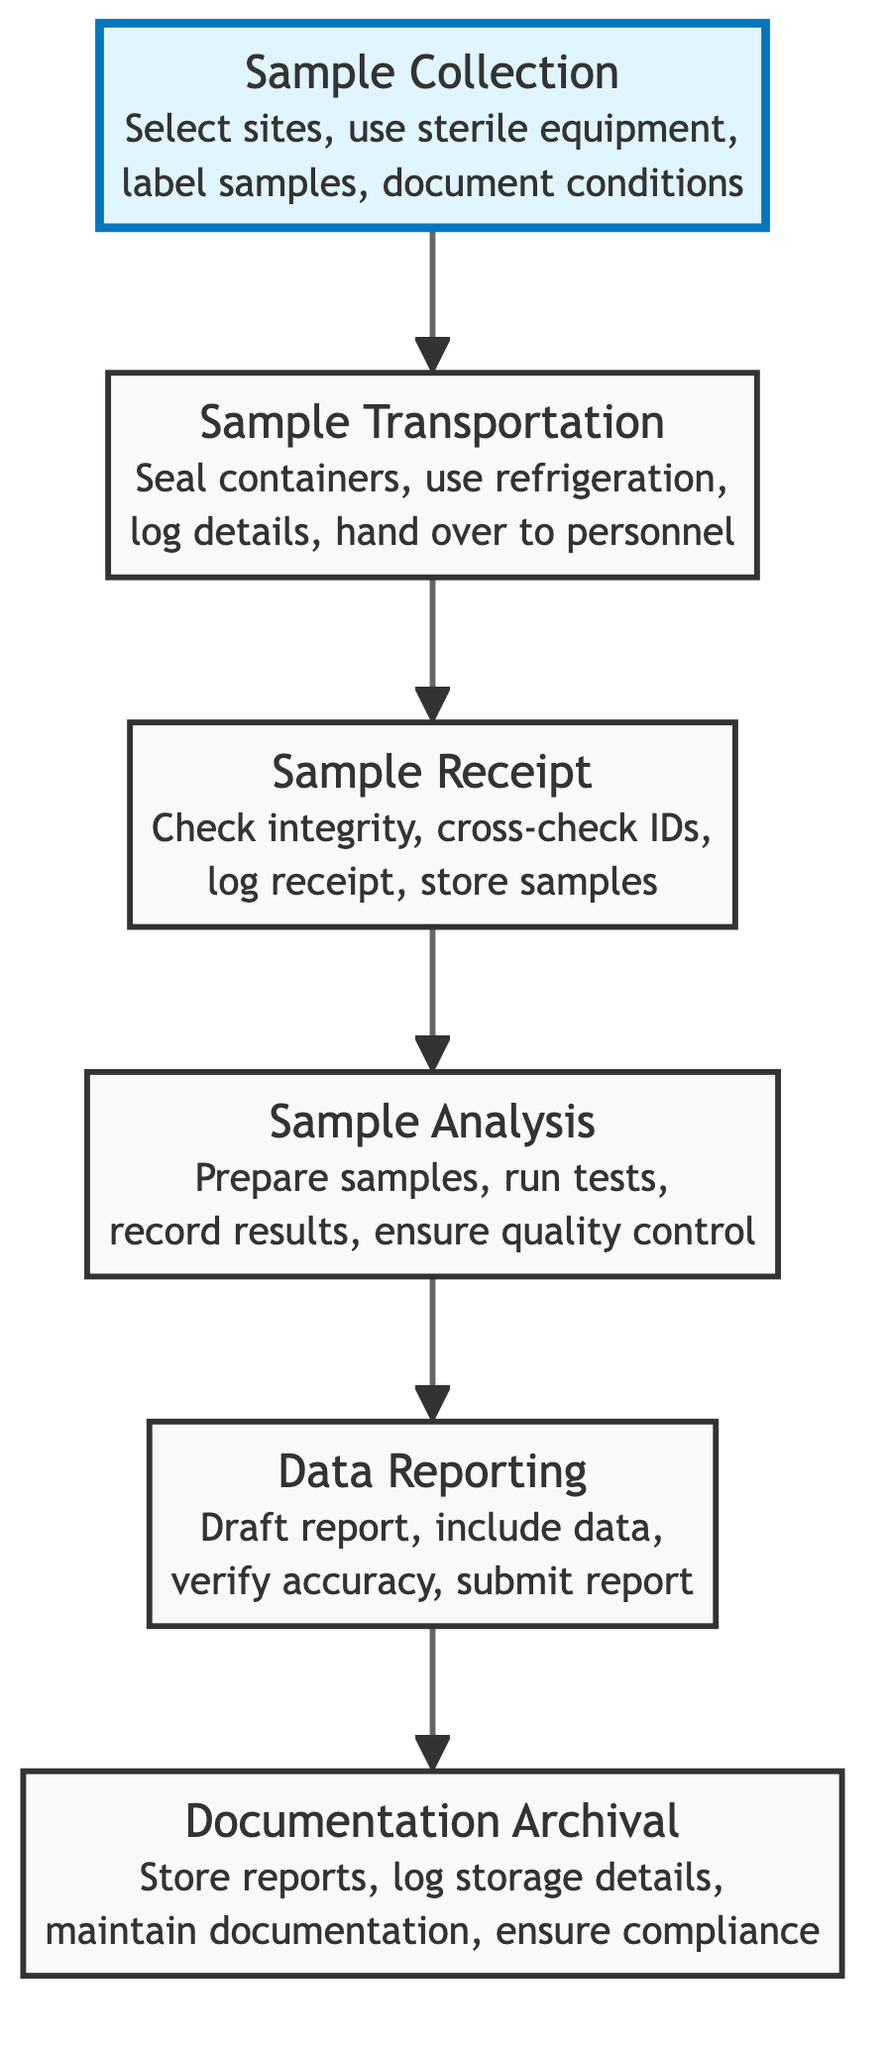What is the first step in the chain of custody documentation process? The flowchart indicates that the first step is "Sample Collection," which involves selecting sampling sites and using sterilized equipment.
Answer: Sample Collection How many nodes are present in the diagram? The diagram contains six nodes representing different steps in the chain of custody documentation process.
Answer: Six Which step is responsible for ensuring compliance with legal requirements? The node "Documentation Archival" is responsible for maintaining compliance with legal requirements following the completion of previous steps.
Answer: Documentation Archival What action is taken in the "Sample Transportation" step? This step includes actions such as placing samples in sealed containers, using refrigerated transport if necessary, and logging transportation details.
Answer: Place samples in sealed containers What does the "Data Reporting" step entail? The "Data Reporting" step includes drafting a detailed report, verifying report accuracy, and submitting the report to relevant parties.
Answer: Draft a detailed report What is the last phase in the diagram's flow? The last phase shown in the flowchart is "Documentation Archival," which ensures that all documentation is stored appropriately for future reference.
Answer: Documentation Archival What action must be completed before samples are analyzed? The action of "Sample Receipt," which includes checking sample integrity and logging receipt information, must be completed before analysis can occur.
Answer: Sample Receipt Which step directly follows "Sample Analysis" in the chain of custody documentation? The step that directly follows "Sample Analysis" is "Data Reporting," where analysis results are compiled and reported.
Answer: Data Reporting What is the key focus of the "Sample Collection" phase? The key focus of the "Sample Collection" phase is to collect ecological samples using standard protocols, including selecting sites and documenting environmental conditions.
Answer: Collect ecological samples 